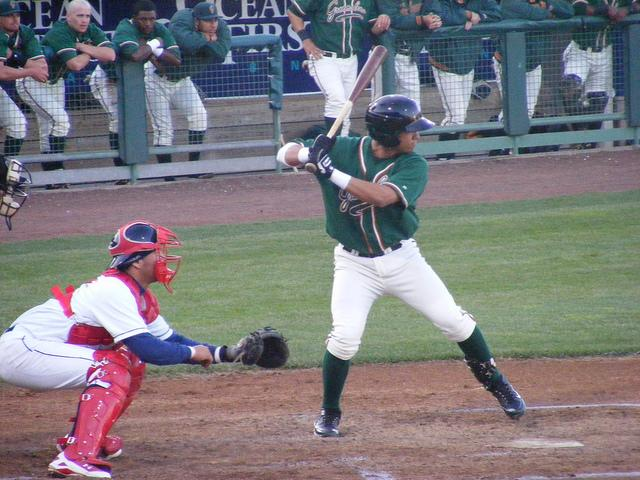What is going to approach the two men in front soon? baseball 